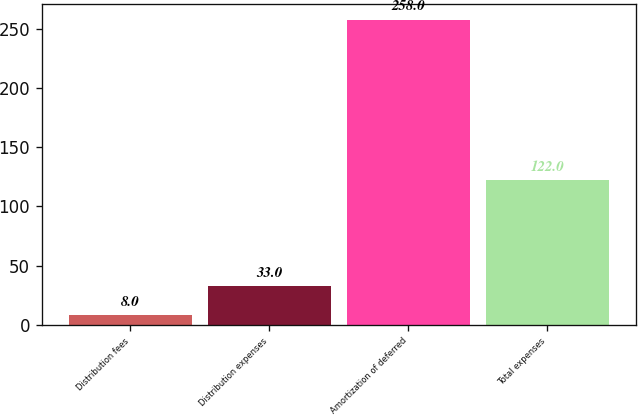Convert chart to OTSL. <chart><loc_0><loc_0><loc_500><loc_500><bar_chart><fcel>Distribution fees<fcel>Distribution expenses<fcel>Amortization of deferred<fcel>Total expenses<nl><fcel>8<fcel>33<fcel>258<fcel>122<nl></chart> 